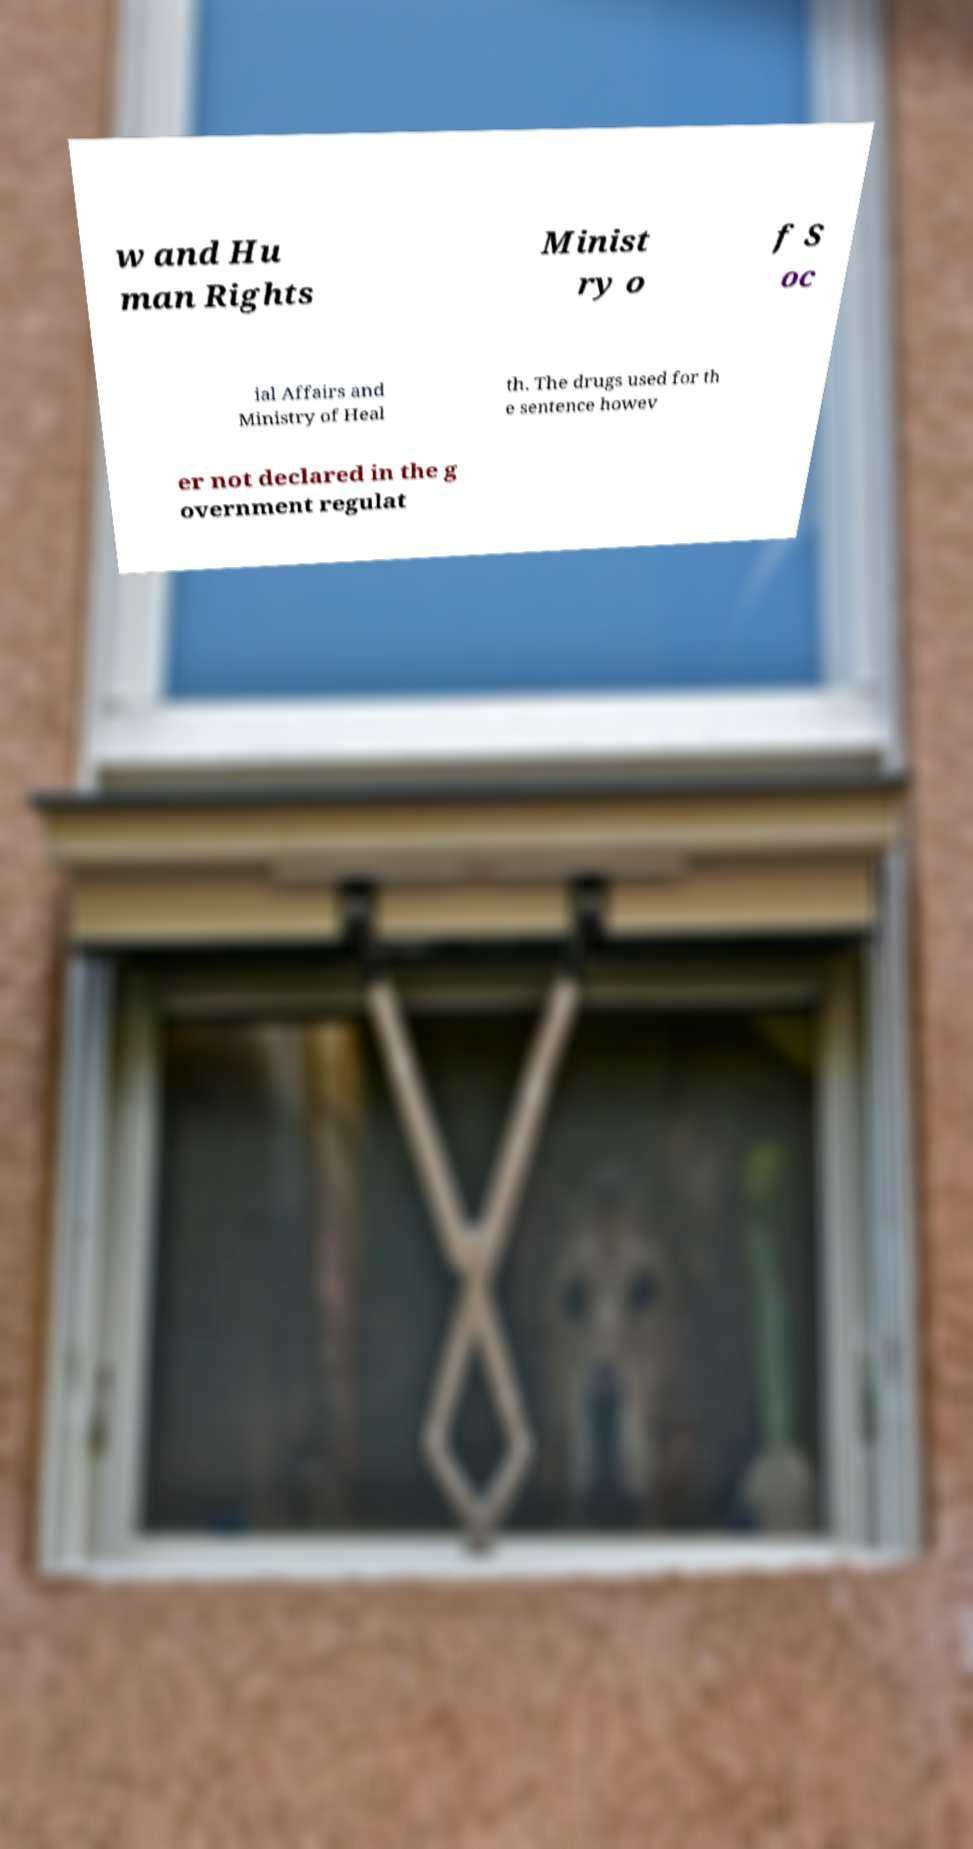Could you assist in decoding the text presented in this image and type it out clearly? w and Hu man Rights Minist ry o f S oc ial Affairs and Ministry of Heal th. The drugs used for th e sentence howev er not declared in the g overnment regulat 